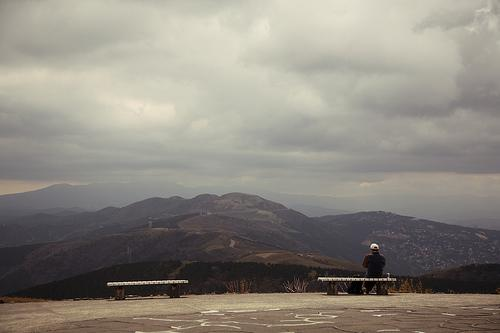Provide an overall summary of the image in one sentence. A gloomy outdoor scene featuring a person with a white hat sitting on a white bench, surrounded by hills and trees, under a cloudy sky. Provide a brief description of the overall setting in the image. The image portrays an outdoor scene with a gloomy sky, hills in the background, covered with trees, and a person sitting on a white bench. Write a short sentence mentioning the state of vegetation in the image. The hills in the background are covered with trees, and there are tree branches scattered around the area. Describe the artistic elements observed on the ground in the image. The ground features unique white drawings on a stoned surface, creating an interesting and textured appearance. Give a brief description of the person's appearance and what they are wearing. The person is sitting on a white bench, wearing a white cap, and appears to be deep in thought. What is the person in the image doing, and where are they located within the scene? The person is sitting on a white bench towards the center of the image, wearing a white hat and appears to be deep in thought under the gloomy sky. Describe the most significant object in the foreground of the image. In the foreground, there is a white bench where a person with a white hat is sitting. Write a short sentence about the weather condition in the image. The weather appears to be overcast and gloomy with grey clouds in the sky. Explain the appearance of the ground in the image. The ground is covered with white drawings on a stoned surface resembling a bare, mountainous terrain. Mention the primary colors seen in the elements of the image and their respective objects. The sky is cloudy and grey, the bench and the hat are both white, and the drawings on the ground are white as well. 